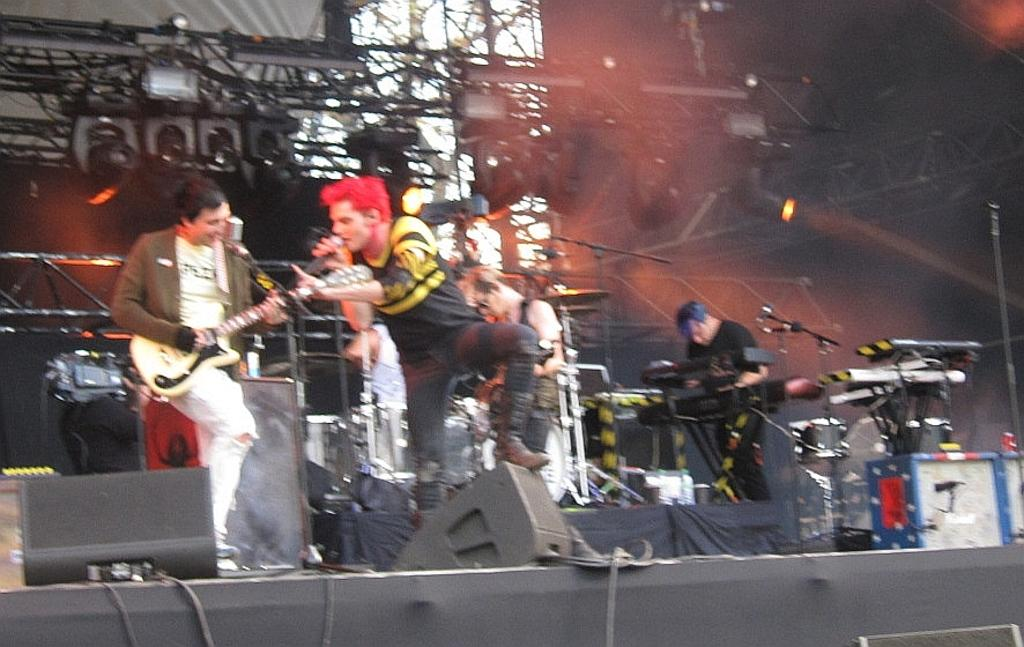What is the person in the foreground of the image doing? The person is holding a mic and singing. What can be seen in the background of the image? There are people playing musical instruments in the background of the image. What objects are visible in the image that are related to the performance? There are rods and lights visible in the image. What type of expansion is being celebrated in the image? There is no indication of an expansion being celebrated in the image. Is there a birthday party happening in the image? There is no indication of a birthday party in the image. Can you see any baseball equipment in the image? There is no baseball equipment visible in the image. 